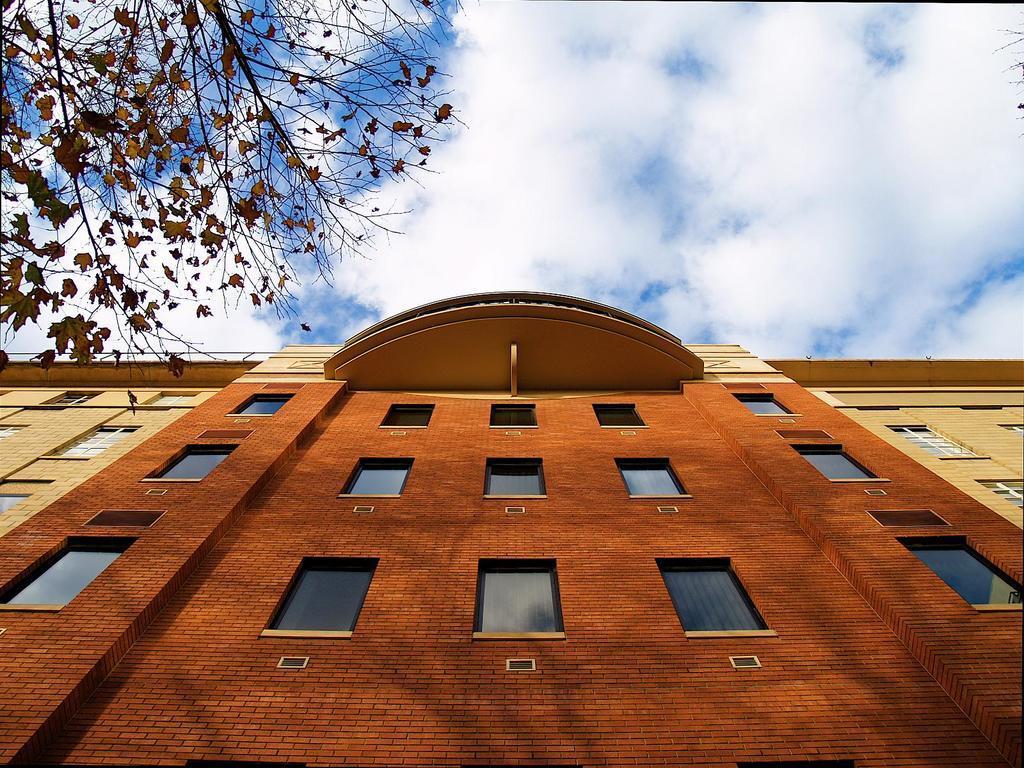Could you give a brief overview of what you see in this image? In the foreground of the picture there is a building with windows. On the left we can see the stems of a tree. On the right we can see the stems of a tree. Sky is partially cloudy 